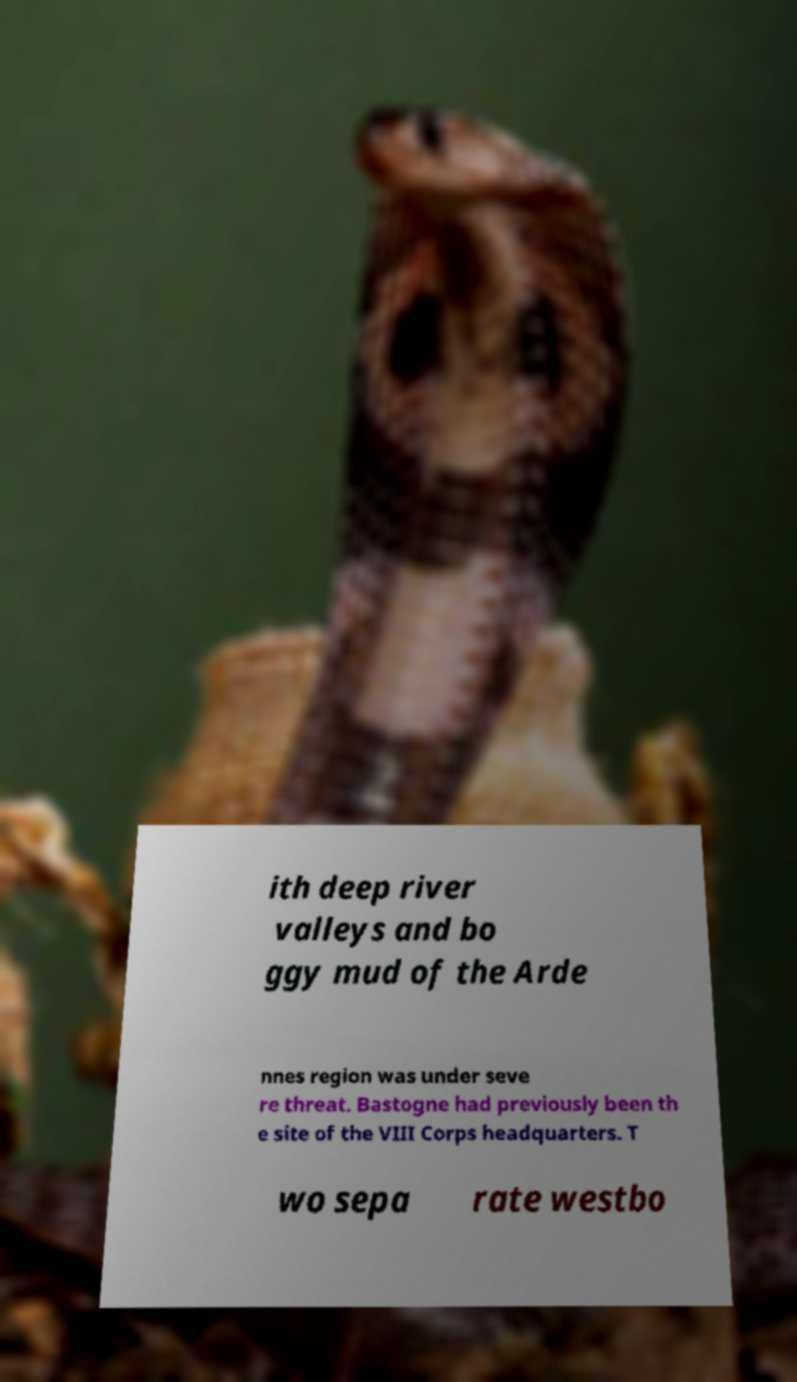Could you assist in decoding the text presented in this image and type it out clearly? ith deep river valleys and bo ggy mud of the Arde nnes region was under seve re threat. Bastogne had previously been th e site of the VIII Corps headquarters. T wo sepa rate westbo 